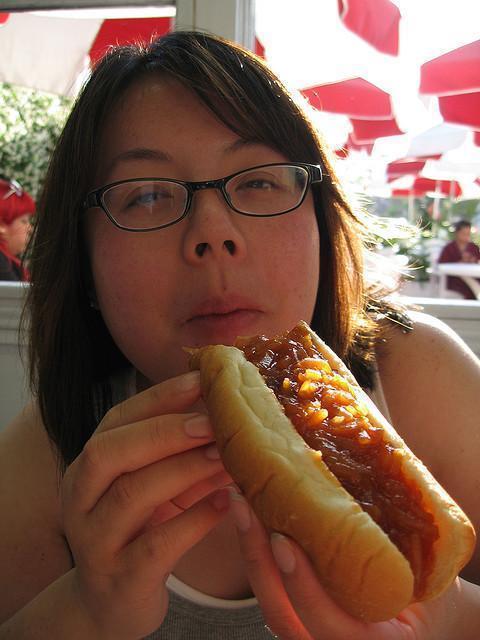In what place was the bread eaten here cooked?
Answer the question by selecting the correct answer among the 4 following choices and explain your choice with a short sentence. The answer should be formatted with the following format: `Answer: choice
Rationale: rationale.`
Options: Grill, oven, deep fryer, fryer. Answer: oven.
Rationale: Bread is baked in an oven. 